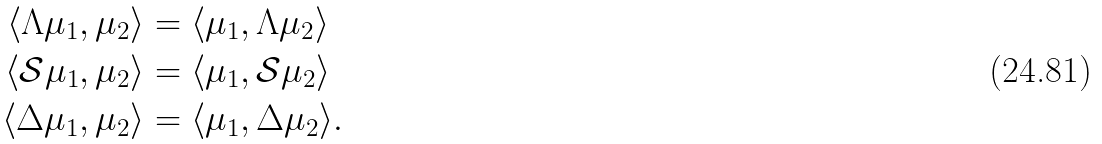<formula> <loc_0><loc_0><loc_500><loc_500>\langle \Lambda \mu _ { 1 } , \mu _ { 2 } \rangle & = \langle \mu _ { 1 } , \Lambda \mu _ { 2 } \rangle \\ \langle \mathcal { S } \mu _ { 1 } , \mu _ { 2 } \rangle & = \langle \mu _ { 1 } , \mathcal { S } \mu _ { 2 } \rangle \\ \langle \Delta \mu _ { 1 } , \mu _ { 2 } \rangle & = \langle \mu _ { 1 } , \Delta \mu _ { 2 } \rangle .</formula> 